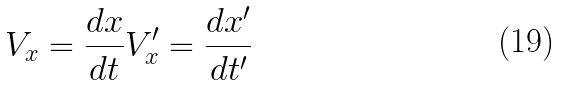<formula> <loc_0><loc_0><loc_500><loc_500>V _ { x } = \frac { d x } { d t } V _ { x } ^ { \prime } = \frac { d x ^ { \prime } } { d t ^ { \prime } }</formula> 